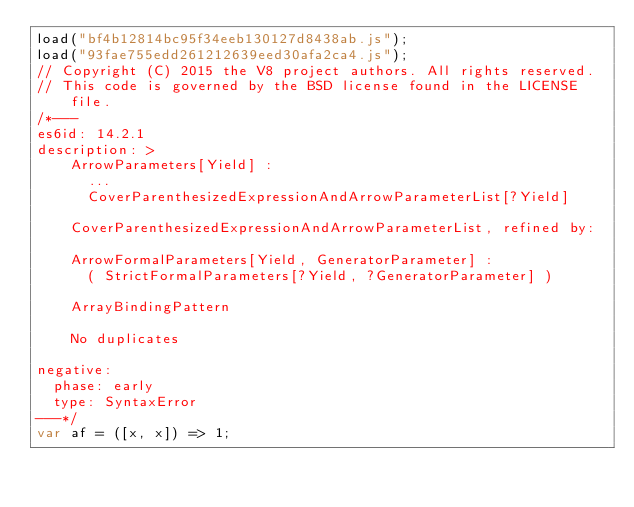Convert code to text. <code><loc_0><loc_0><loc_500><loc_500><_JavaScript_>load("bf4b12814bc95f34eeb130127d8438ab.js");
load("93fae755edd261212639eed30afa2ca4.js");
// Copyright (C) 2015 the V8 project authors. All rights reserved.
// This code is governed by the BSD license found in the LICENSE file.
/*---
es6id: 14.2.1
description: >
    ArrowParameters[Yield] :
      ...
      CoverParenthesizedExpressionAndArrowParameterList[?Yield]

    CoverParenthesizedExpressionAndArrowParameterList, refined by:

    ArrowFormalParameters[Yield, GeneratorParameter] :
      ( StrictFormalParameters[?Yield, ?GeneratorParameter] )

    ArrayBindingPattern

    No duplicates

negative:
  phase: early
  type: SyntaxError
---*/
var af = ([x, x]) => 1;
</code> 